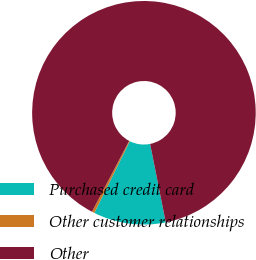<chart> <loc_0><loc_0><loc_500><loc_500><pie_chart><fcel>Purchased credit card<fcel>Other customer relationships<fcel>Other<nl><fcel>10.45%<fcel>0.37%<fcel>89.18%<nl></chart> 